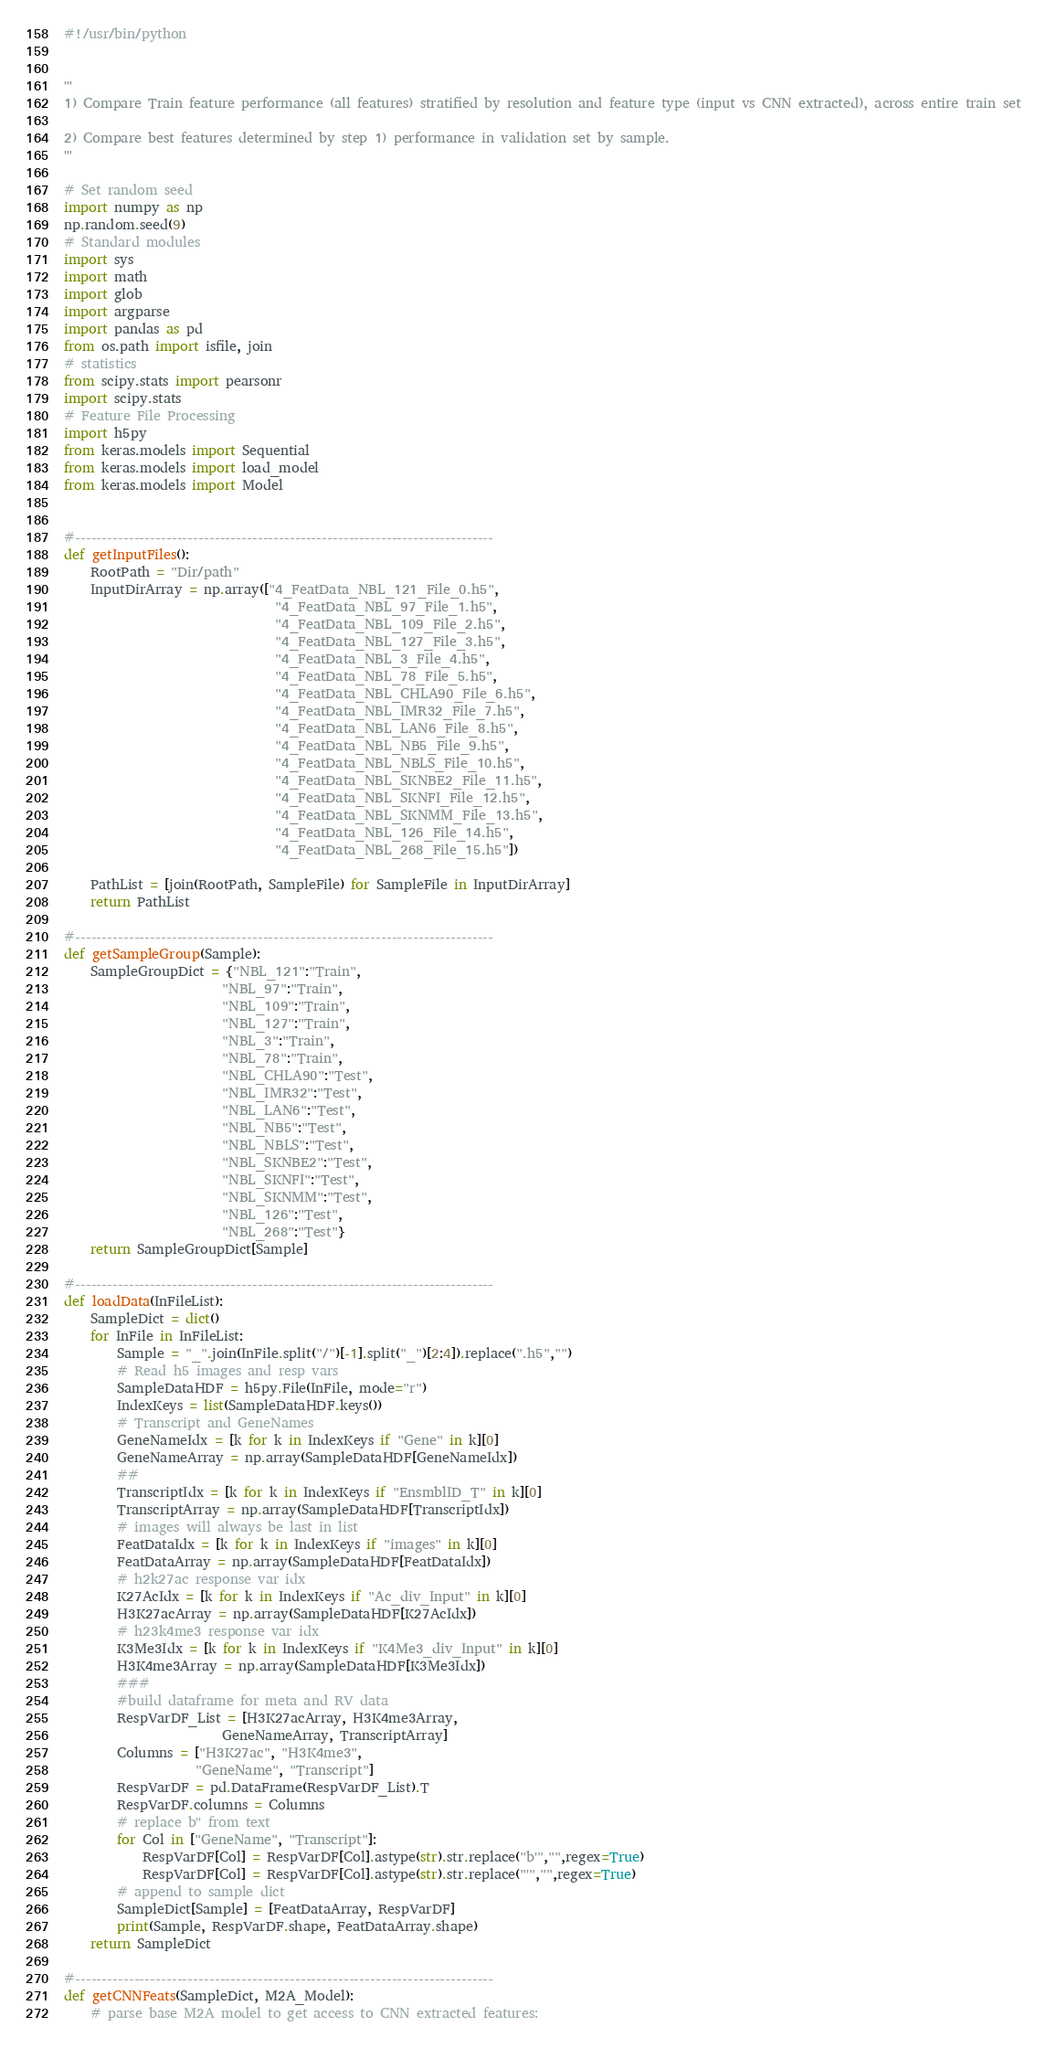<code> <loc_0><loc_0><loc_500><loc_500><_Python_>#!/usr/bin/python


'''
1) Compare Train feature performance (all features) stratified by resolution and feature type (input vs CNN extracted), across entire train set

2) Compare best features determined by step 1) performance in validation set by sample.
'''

# Set random seed
import numpy as np
np.random.seed(9)
# Standard modules
import sys
import math
import glob
import argparse
import pandas as pd
from os.path import isfile, join
# statistics
from scipy.stats import pearsonr
import scipy.stats
# Feature File Processing
import h5py
from keras.models import Sequential
from keras.models import load_model
from keras.models import Model


#------------------------------------------------------------------------------
def getInputFiles():
	RootPath = "Dir/path"
	InputDirArray = np.array(["4_FeatData_NBL_121_File_0.h5",
								"4_FeatData_NBL_97_File_1.h5",
								"4_FeatData_NBL_109_File_2.h5",
								"4_FeatData_NBL_127_File_3.h5",
								"4_FeatData_NBL_3_File_4.h5",
								"4_FeatData_NBL_78_File_5.h5",
								"4_FeatData_NBL_CHLA90_File_6.h5",
								"4_FeatData_NBL_IMR32_File_7.h5",
								"4_FeatData_NBL_LAN6_File_8.h5",
								"4_FeatData_NBL_NB5_File_9.h5",
								"4_FeatData_NBL_NBLS_File_10.h5",
								"4_FeatData_NBL_SKNBE2_File_11.h5",
								"4_FeatData_NBL_SKNFI_File_12.h5",
								"4_FeatData_NBL_SKNMM_File_13.h5",
								"4_FeatData_NBL_126_File_14.h5",
								"4_FeatData_NBL_268_File_15.h5"])

	PathList = [join(RootPath, SampleFile) for SampleFile in InputDirArray]
	return PathList

#------------------------------------------------------------------------------
def getSampleGroup(Sample):
	SampleGroupDict = {"NBL_121":"Train",
						"NBL_97":"Train",
						"NBL_109":"Train",
						"NBL_127":"Train",
						"NBL_3":"Train",
						"NBL_78":"Train",
						"NBL_CHLA90":"Test",
						"NBL_IMR32":"Test",
						"NBL_LAN6":"Test",
						"NBL_NB5":"Test",
						"NBL_NBLS":"Test",
						"NBL_SKNBE2":"Test",
						"NBL_SKNFI":"Test",
						"NBL_SKNMM":"Test",
						"NBL_126":"Test",
						"NBL_268":"Test"}
	return SampleGroupDict[Sample]

#------------------------------------------------------------------------------
def loadData(InFileList):
	SampleDict = dict()
	for InFile in InFileList:
		Sample = "_".join(InFile.split("/")[-1].split("_")[2:4]).replace(".h5","")
		# Read h5 images and resp vars
		SampleDataHDF = h5py.File(InFile, mode="r")
		IndexKeys = list(SampleDataHDF.keys())
		# Transcript and GeneNames
		GeneNameIdx = [k for k in IndexKeys if "Gene" in k][0]
		GeneNameArray = np.array(SampleDataHDF[GeneNameIdx])
		##
		TranscriptIdx = [k for k in IndexKeys if "EnsmblID_T" in k][0]
		TranscriptArray = np.array(SampleDataHDF[TranscriptIdx])
		# images will always be last in list
		FeatDataIdx = [k for k in IndexKeys if "images" in k][0]
		FeatDataArray = np.array(SampleDataHDF[FeatDataIdx])
		# h2k27ac response var idx
		K27AcIdx = [k for k in IndexKeys if "Ac_div_Input" in k][0]
		H3K27acArray = np.array(SampleDataHDF[K27AcIdx])
		# h23k4me3 response var idx
		K3Me3Idx = [k for k in IndexKeys if "K4Me3_div_Input" in k][0]
		H3K4me3Array = np.array(SampleDataHDF[K3Me3Idx])
		###
		#build dataframe for meta and RV data
		RespVarDF_List = [H3K27acArray, H3K4me3Array, 
						GeneNameArray, TranscriptArray]
		Columns = ["H3K27ac", "H3K4me3", 
					"GeneName", "Transcript"]
		RespVarDF = pd.DataFrame(RespVarDF_List).T
		RespVarDF.columns = Columns
		# replace b'' from text
		for Col in ["GeneName", "Transcript"]:
			RespVarDF[Col] = RespVarDF[Col].astype(str).str.replace("b'","",regex=True)
			RespVarDF[Col] = RespVarDF[Col].astype(str).str.replace("'","",regex=True)
		# append to sample dict
		SampleDict[Sample] = [FeatDataArray, RespVarDF]
		print(Sample, RespVarDF.shape, FeatDataArray.shape)
	return SampleDict 

#------------------------------------------------------------------------------
def getCNNFeats(SampleDict, M2A_Model):
	# parse base M2A model to get access to CNN extracted features:</code> 